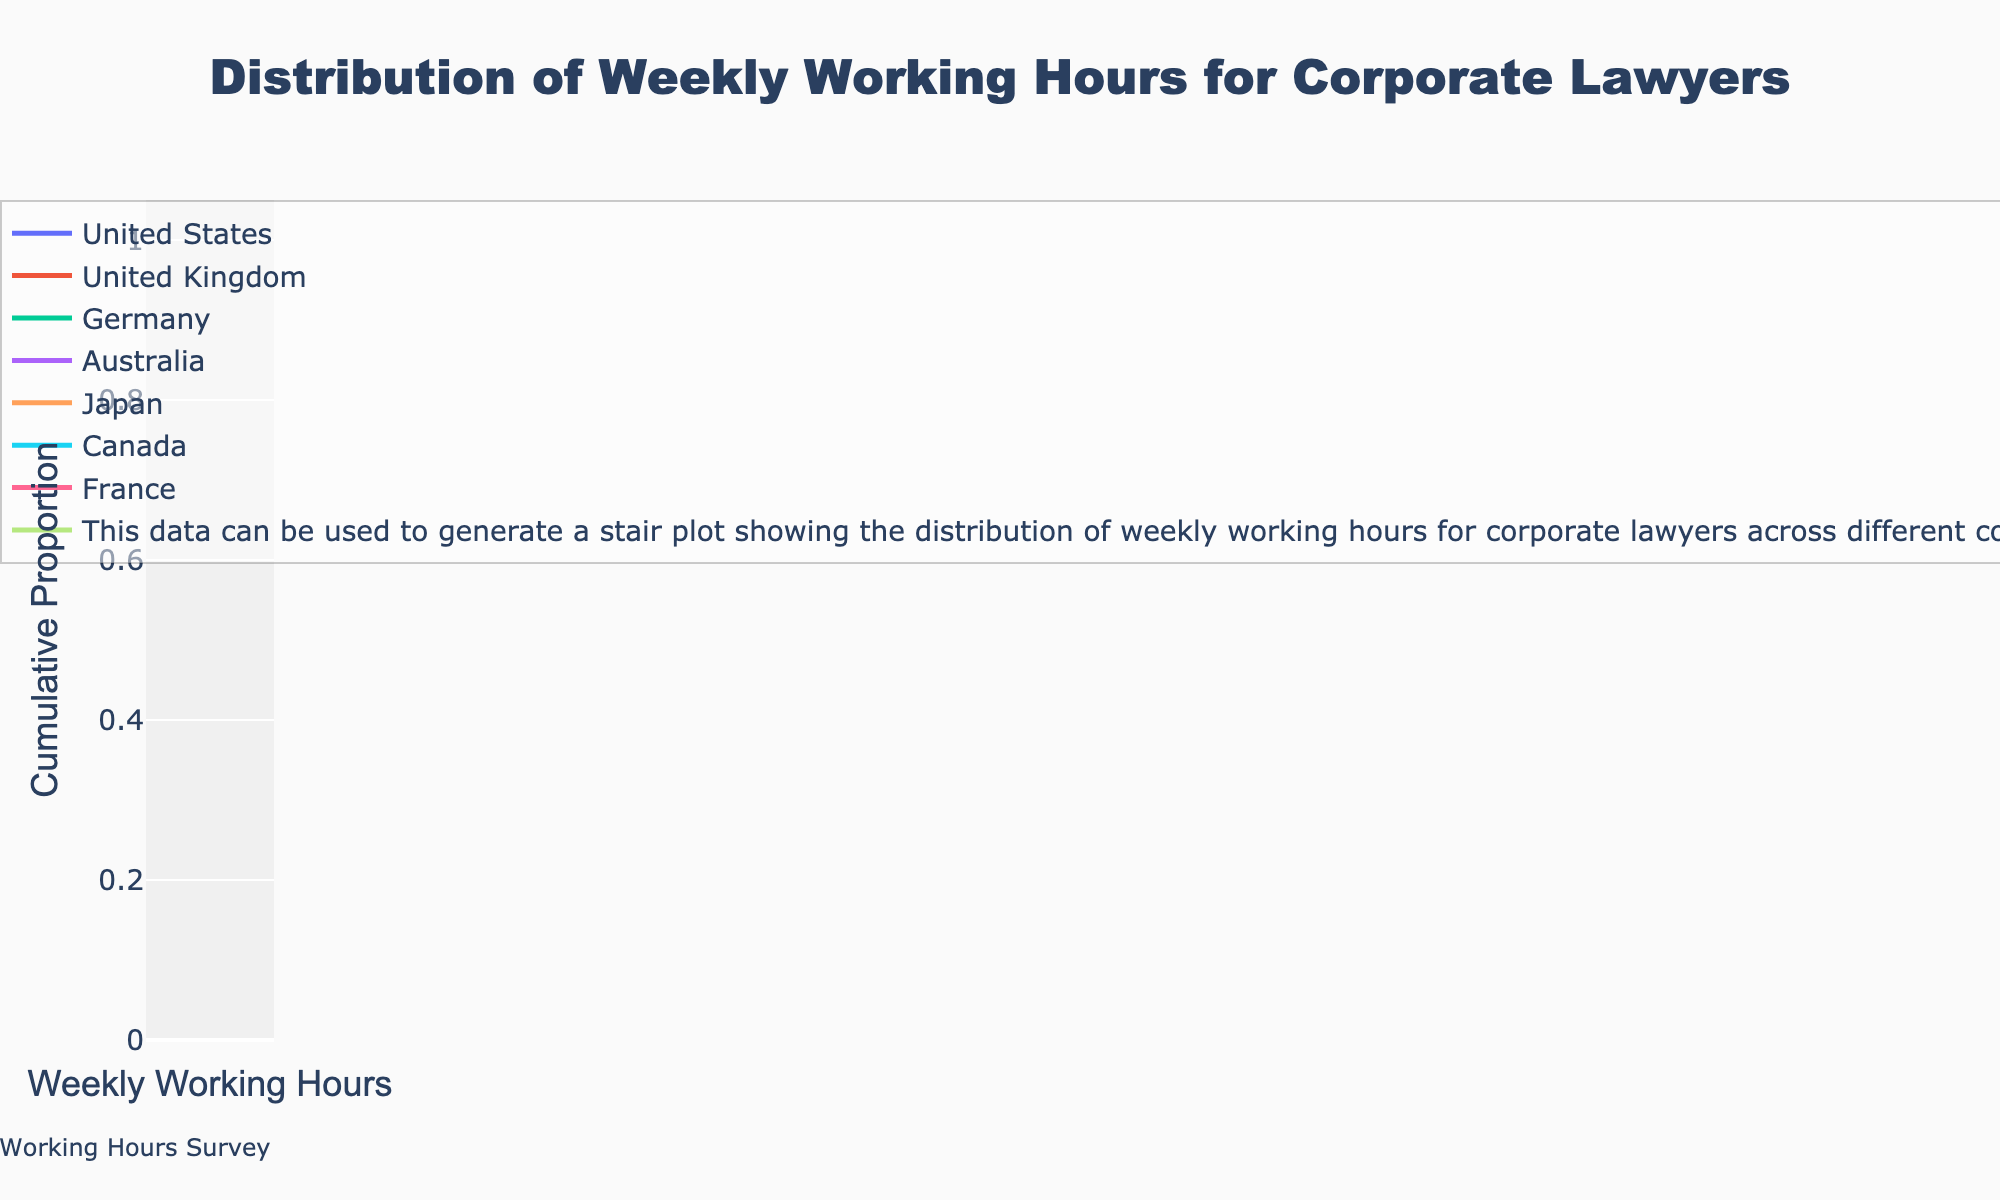What's the range of weekly working hours for corporate lawyers in the United States? The range can be identified by the minimum and maximum values on the x-axis for the United States' line. The values range from 45 to 60.
Answer: 45-60 Which country has the highest maximum weekly working hours for corporate lawyers? By examining the highest endpoint on the x-axis for each country's line, Japan has the maximum at 65 hours.
Answer: Japan How do the median weekly working hours for corporate lawyers in Germany compare to those in France? For Germany, the median (middle) value after sorting is between 49 and 52 hours. For France, the median value is between 42 and 45 hours. Therefore, Germany's median is higher than France's median.
Answer: Germany’s median is higher What proportion of corporate lawyers in the United Kingdom work more than 55 hours per week? Identify the y-value at 55 hours on the United Kingdom line. It corresponds to a cumulative proportion. Approximately 25% of lawyers work more than 55 hours as the value at 55 hours is around 0.75.
Answer: 25% Which country shows the least variability in weekly working hours? The country with the smallest range on the x-axis has the least variability. France ranges from 37 to 48, indicating the least variability.
Answer: France What is the cumulative proportion of corporate lawyers in Australia working 50 hours or fewer per week? Locate the point at 50 hours on the Australian line and read the y-value. The cumulative proportion is approximately 0.5 or 50%.
Answer: 50% Do corporate lawyers in Canada generally work fewer hours than those in Japan? Compare the distributions as shown by the lines. Japan's working hours are significantly higher overall, with hours ranging from 59 to 65. Canada's hours range from 45 to 60, which is generally lower than Japan’s.
Answer: Yes What's the minimum working hour recorded for corporate lawyers in Germany? By identifying the lowest x-value on Germany's line, the minimum working hours is found to be 48 hours.
Answer: 48 What is the cumulative proportion of corporate lawyers working 55 hours or fewer per week in the United States? Find the y-value at 55 hours on the United States' line. The cumulative proportion is around 0.75 or 75%.
Answer: 75% Which country has the steepest increase in cumulative proportion around the 60-hour mark? By examining the slopes of the lines at around 60 hours, Japan’s line shows a very steep increase, indicating a significant rise in cumulative proportion around that duration.
Answer: Japan 